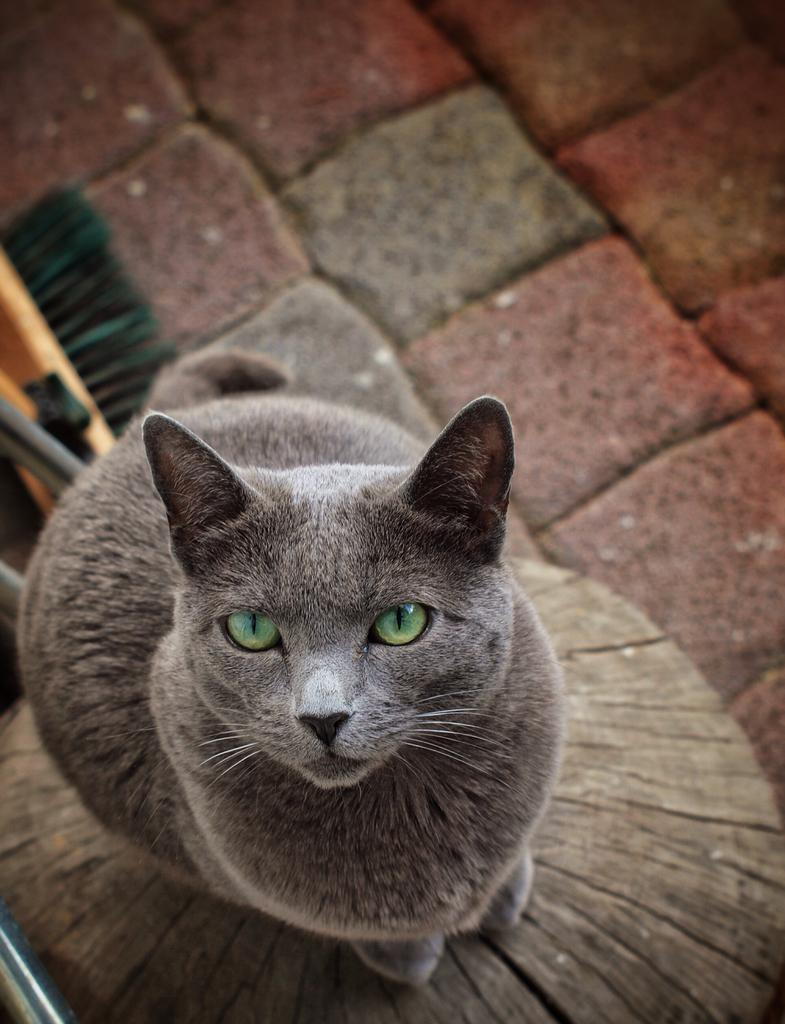What type of animal is in the image? There is a cat in the image. What is the cat standing on in the image? The cat is standing on an object. What else can be seen on the floor in the image? There are other things on the floor in the image. Can you see any twigs in the image? There is no mention of twigs in the image; it features a cat standing on an object and other things on the floor. How many rings is the cat wearing in the image? The image does not show the cat wearing any rings. 